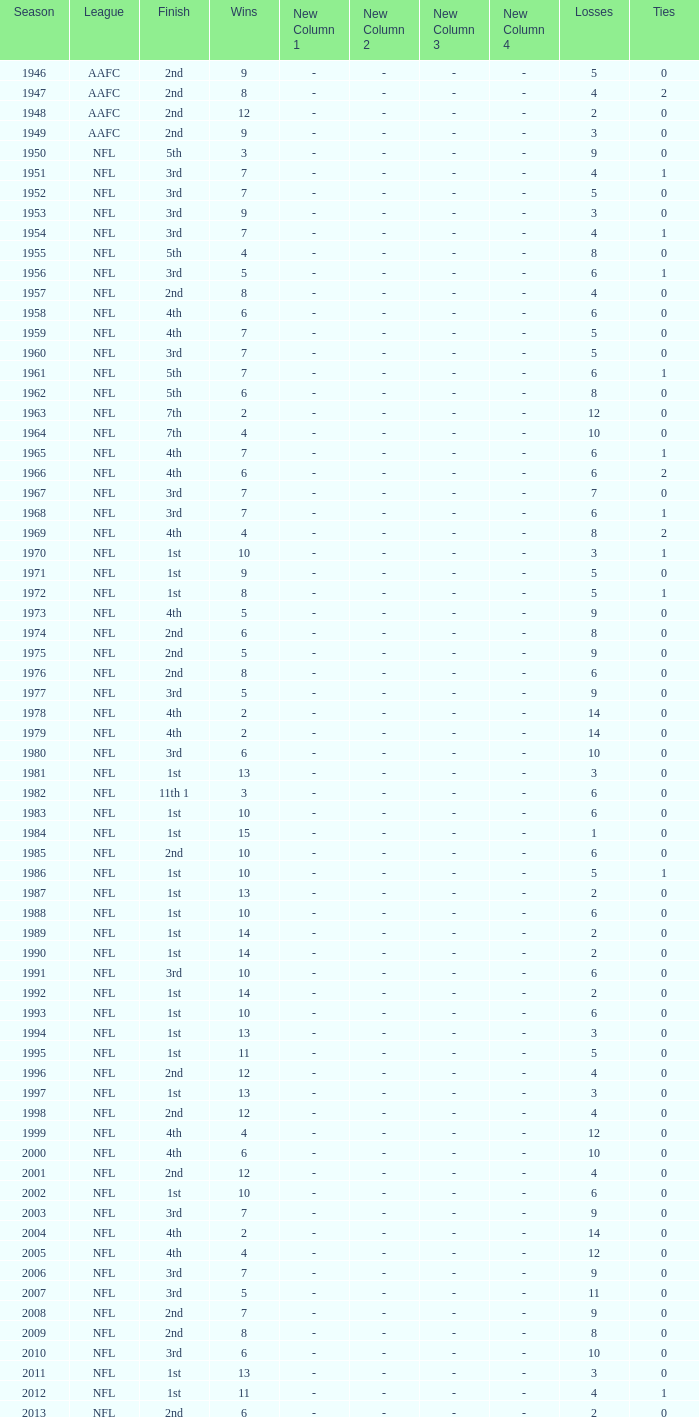When ties are below 0, what is the quantity of losses? 0.0. 